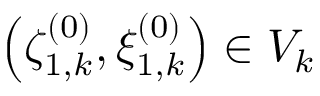<formula> <loc_0><loc_0><loc_500><loc_500>\left ( \zeta _ { 1 , k } ^ { ( 0 ) } , \xi _ { 1 , k } ^ { ( 0 ) } \right ) \in V _ { k }</formula> 